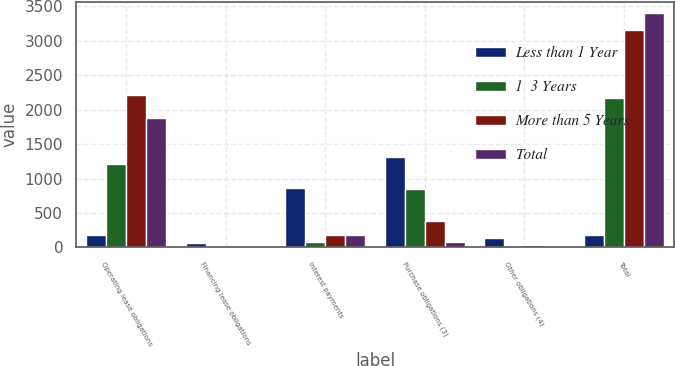Convert chart. <chart><loc_0><loc_0><loc_500><loc_500><stacked_bar_chart><ecel><fcel>Operating lease obligations<fcel>Financing lease obligations<fcel>Interest payments<fcel>Purchase obligations (3)<fcel>Other obligations (4)<fcel>Total<nl><fcel>Less than 1 Year<fcel>179.25<fcel>59.1<fcel>868.9<fcel>1310.1<fcel>134.7<fcel>179.25<nl><fcel>1  3 Years<fcel>1213.1<fcel>4.1<fcel>83.6<fcel>848.1<fcel>20.3<fcel>2169.2<nl><fcel>More than 5 Years<fcel>2210.2<fcel>8.2<fcel>185.6<fcel>380.1<fcel>28.1<fcel>3162.2<nl><fcel>Total<fcel>1875<fcel>7.9<fcel>172.9<fcel>73.6<fcel>18.8<fcel>3398.2<nl></chart> 